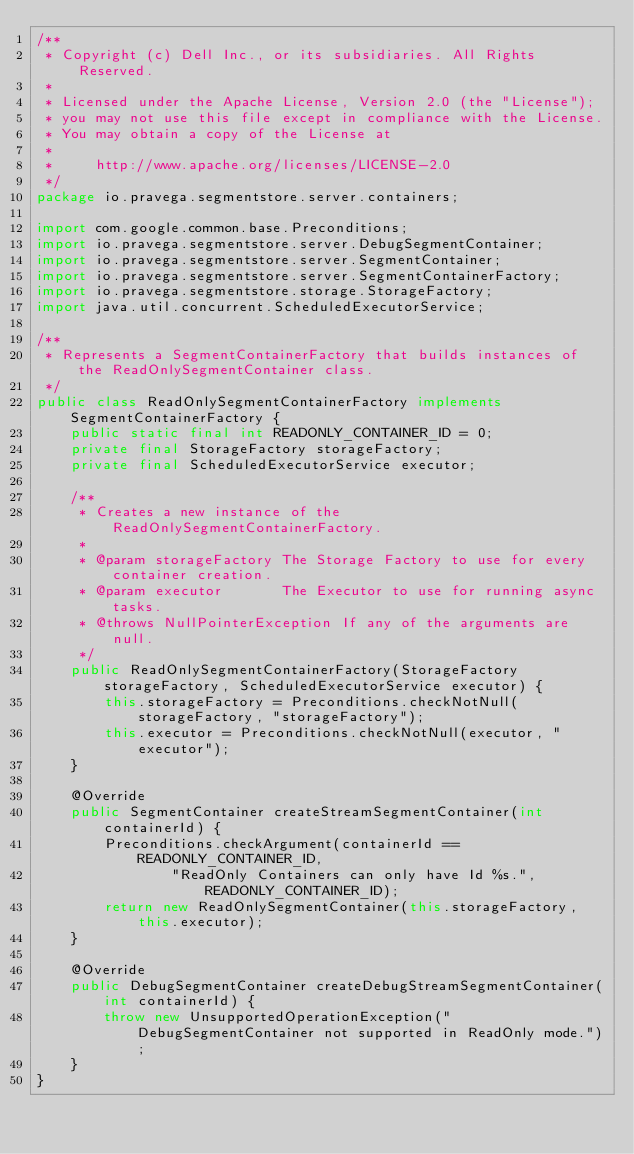<code> <loc_0><loc_0><loc_500><loc_500><_Java_>/**
 * Copyright (c) Dell Inc., or its subsidiaries. All Rights Reserved.
 *
 * Licensed under the Apache License, Version 2.0 (the "License");
 * you may not use this file except in compliance with the License.
 * You may obtain a copy of the License at
 *
 *     http://www.apache.org/licenses/LICENSE-2.0
 */
package io.pravega.segmentstore.server.containers;

import com.google.common.base.Preconditions;
import io.pravega.segmentstore.server.DebugSegmentContainer;
import io.pravega.segmentstore.server.SegmentContainer;
import io.pravega.segmentstore.server.SegmentContainerFactory;
import io.pravega.segmentstore.storage.StorageFactory;
import java.util.concurrent.ScheduledExecutorService;

/**
 * Represents a SegmentContainerFactory that builds instances of the ReadOnlySegmentContainer class.
 */
public class ReadOnlySegmentContainerFactory implements SegmentContainerFactory {
    public static final int READONLY_CONTAINER_ID = 0;
    private final StorageFactory storageFactory;
    private final ScheduledExecutorService executor;

    /**
     * Creates a new instance of the ReadOnlySegmentContainerFactory.
     *
     * @param storageFactory The Storage Factory to use for every container creation.
     * @param executor       The Executor to use for running async tasks.
     * @throws NullPointerException If any of the arguments are null.
     */
    public ReadOnlySegmentContainerFactory(StorageFactory storageFactory, ScheduledExecutorService executor) {
        this.storageFactory = Preconditions.checkNotNull(storageFactory, "storageFactory");
        this.executor = Preconditions.checkNotNull(executor, "executor");
    }

    @Override
    public SegmentContainer createStreamSegmentContainer(int containerId) {
        Preconditions.checkArgument(containerId == READONLY_CONTAINER_ID,
                "ReadOnly Containers can only have Id %s.", READONLY_CONTAINER_ID);
        return new ReadOnlySegmentContainer(this.storageFactory, this.executor);
    }

    @Override
    public DebugSegmentContainer createDebugStreamSegmentContainer(int containerId) {
        throw new UnsupportedOperationException("DebugSegmentContainer not supported in ReadOnly mode.");
    }
}
</code> 